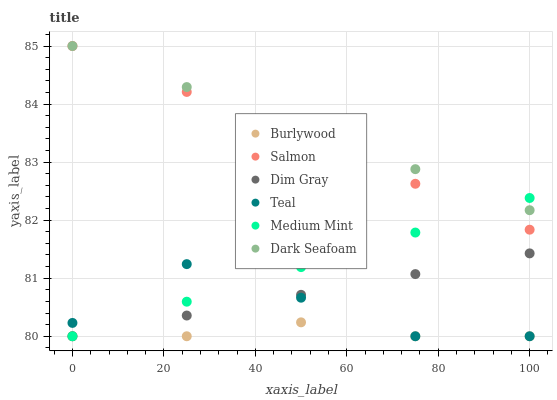Does Burlywood have the minimum area under the curve?
Answer yes or no. Yes. Does Dark Seafoam have the maximum area under the curve?
Answer yes or no. Yes. Does Dim Gray have the minimum area under the curve?
Answer yes or no. No. Does Dim Gray have the maximum area under the curve?
Answer yes or no. No. Is Salmon the smoothest?
Answer yes or no. Yes. Is Teal the roughest?
Answer yes or no. Yes. Is Dim Gray the smoothest?
Answer yes or no. No. Is Dim Gray the roughest?
Answer yes or no. No. Does Medium Mint have the lowest value?
Answer yes or no. Yes. Does Salmon have the lowest value?
Answer yes or no. No. Does Dark Seafoam have the highest value?
Answer yes or no. Yes. Does Dim Gray have the highest value?
Answer yes or no. No. Is Burlywood less than Dark Seafoam?
Answer yes or no. Yes. Is Dark Seafoam greater than Dim Gray?
Answer yes or no. Yes. Does Burlywood intersect Medium Mint?
Answer yes or no. Yes. Is Burlywood less than Medium Mint?
Answer yes or no. No. Is Burlywood greater than Medium Mint?
Answer yes or no. No. Does Burlywood intersect Dark Seafoam?
Answer yes or no. No. 